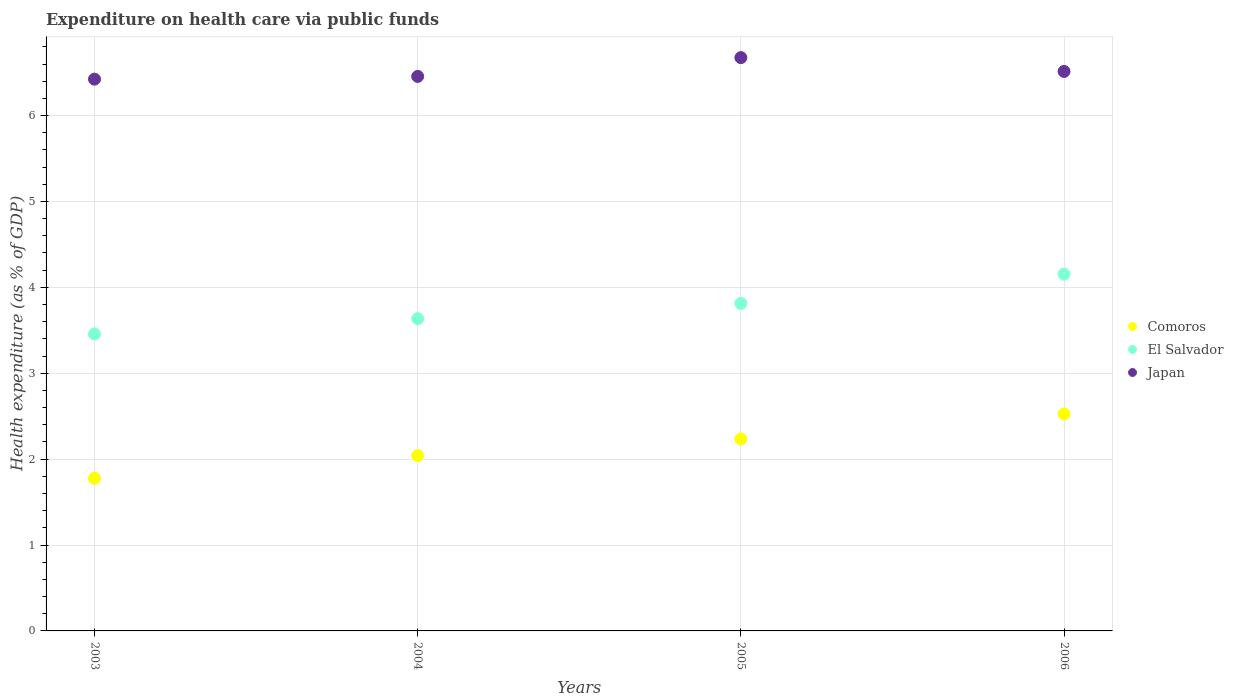Is the number of dotlines equal to the number of legend labels?
Your answer should be very brief. Yes. What is the expenditure made on health care in Japan in 2003?
Provide a short and direct response. 6.42. Across all years, what is the maximum expenditure made on health care in Comoros?
Give a very brief answer. 2.53. Across all years, what is the minimum expenditure made on health care in Japan?
Your answer should be compact. 6.42. In which year was the expenditure made on health care in El Salvador minimum?
Offer a very short reply. 2003. What is the total expenditure made on health care in Japan in the graph?
Your answer should be very brief. 26.07. What is the difference between the expenditure made on health care in Japan in 2003 and that in 2004?
Ensure brevity in your answer.  -0.03. What is the difference between the expenditure made on health care in Comoros in 2006 and the expenditure made on health care in El Salvador in 2005?
Your answer should be very brief. -1.29. What is the average expenditure made on health care in Comoros per year?
Your response must be concise. 2.14. In the year 2006, what is the difference between the expenditure made on health care in Comoros and expenditure made on health care in El Salvador?
Give a very brief answer. -1.63. What is the ratio of the expenditure made on health care in Comoros in 2003 to that in 2005?
Make the answer very short. 0.8. Is the difference between the expenditure made on health care in Comoros in 2004 and 2005 greater than the difference between the expenditure made on health care in El Salvador in 2004 and 2005?
Your answer should be very brief. No. What is the difference between the highest and the second highest expenditure made on health care in Comoros?
Make the answer very short. 0.29. What is the difference between the highest and the lowest expenditure made on health care in Japan?
Provide a succinct answer. 0.25. In how many years, is the expenditure made on health care in El Salvador greater than the average expenditure made on health care in El Salvador taken over all years?
Keep it short and to the point. 2. Is the sum of the expenditure made on health care in El Salvador in 2003 and 2006 greater than the maximum expenditure made on health care in Japan across all years?
Keep it short and to the point. Yes. Is it the case that in every year, the sum of the expenditure made on health care in El Salvador and expenditure made on health care in Japan  is greater than the expenditure made on health care in Comoros?
Make the answer very short. Yes. Does the expenditure made on health care in Japan monotonically increase over the years?
Your answer should be compact. No. How many years are there in the graph?
Offer a very short reply. 4. What is the difference between two consecutive major ticks on the Y-axis?
Provide a succinct answer. 1. Does the graph contain any zero values?
Ensure brevity in your answer.  No. How many legend labels are there?
Keep it short and to the point. 3. How are the legend labels stacked?
Offer a very short reply. Vertical. What is the title of the graph?
Offer a terse response. Expenditure on health care via public funds. Does "Ireland" appear as one of the legend labels in the graph?
Provide a short and direct response. No. What is the label or title of the X-axis?
Provide a short and direct response. Years. What is the label or title of the Y-axis?
Make the answer very short. Health expenditure (as % of GDP). What is the Health expenditure (as % of GDP) of Comoros in 2003?
Keep it short and to the point. 1.78. What is the Health expenditure (as % of GDP) of El Salvador in 2003?
Make the answer very short. 3.46. What is the Health expenditure (as % of GDP) in Japan in 2003?
Your response must be concise. 6.42. What is the Health expenditure (as % of GDP) of Comoros in 2004?
Your response must be concise. 2.04. What is the Health expenditure (as % of GDP) of El Salvador in 2004?
Your response must be concise. 3.64. What is the Health expenditure (as % of GDP) in Japan in 2004?
Your answer should be very brief. 6.46. What is the Health expenditure (as % of GDP) in Comoros in 2005?
Give a very brief answer. 2.23. What is the Health expenditure (as % of GDP) of El Salvador in 2005?
Your response must be concise. 3.81. What is the Health expenditure (as % of GDP) of Japan in 2005?
Your answer should be very brief. 6.67. What is the Health expenditure (as % of GDP) of Comoros in 2006?
Your answer should be compact. 2.53. What is the Health expenditure (as % of GDP) in El Salvador in 2006?
Your answer should be very brief. 4.15. What is the Health expenditure (as % of GDP) of Japan in 2006?
Your response must be concise. 6.51. Across all years, what is the maximum Health expenditure (as % of GDP) in Comoros?
Your response must be concise. 2.53. Across all years, what is the maximum Health expenditure (as % of GDP) of El Salvador?
Give a very brief answer. 4.15. Across all years, what is the maximum Health expenditure (as % of GDP) in Japan?
Offer a very short reply. 6.67. Across all years, what is the minimum Health expenditure (as % of GDP) in Comoros?
Offer a terse response. 1.78. Across all years, what is the minimum Health expenditure (as % of GDP) in El Salvador?
Your answer should be very brief. 3.46. Across all years, what is the minimum Health expenditure (as % of GDP) of Japan?
Provide a short and direct response. 6.42. What is the total Health expenditure (as % of GDP) in Comoros in the graph?
Your answer should be compact. 8.58. What is the total Health expenditure (as % of GDP) in El Salvador in the graph?
Your answer should be very brief. 15.06. What is the total Health expenditure (as % of GDP) of Japan in the graph?
Offer a terse response. 26.07. What is the difference between the Health expenditure (as % of GDP) of Comoros in 2003 and that in 2004?
Provide a succinct answer. -0.27. What is the difference between the Health expenditure (as % of GDP) in El Salvador in 2003 and that in 2004?
Offer a very short reply. -0.18. What is the difference between the Health expenditure (as % of GDP) in Japan in 2003 and that in 2004?
Provide a short and direct response. -0.03. What is the difference between the Health expenditure (as % of GDP) of Comoros in 2003 and that in 2005?
Provide a succinct answer. -0.46. What is the difference between the Health expenditure (as % of GDP) in El Salvador in 2003 and that in 2005?
Your answer should be compact. -0.36. What is the difference between the Health expenditure (as % of GDP) in Japan in 2003 and that in 2005?
Keep it short and to the point. -0.25. What is the difference between the Health expenditure (as % of GDP) of Comoros in 2003 and that in 2006?
Provide a succinct answer. -0.75. What is the difference between the Health expenditure (as % of GDP) in El Salvador in 2003 and that in 2006?
Your response must be concise. -0.7. What is the difference between the Health expenditure (as % of GDP) in Japan in 2003 and that in 2006?
Your answer should be compact. -0.09. What is the difference between the Health expenditure (as % of GDP) in Comoros in 2004 and that in 2005?
Make the answer very short. -0.19. What is the difference between the Health expenditure (as % of GDP) of El Salvador in 2004 and that in 2005?
Keep it short and to the point. -0.18. What is the difference between the Health expenditure (as % of GDP) of Japan in 2004 and that in 2005?
Ensure brevity in your answer.  -0.22. What is the difference between the Health expenditure (as % of GDP) of Comoros in 2004 and that in 2006?
Keep it short and to the point. -0.48. What is the difference between the Health expenditure (as % of GDP) in El Salvador in 2004 and that in 2006?
Your response must be concise. -0.52. What is the difference between the Health expenditure (as % of GDP) in Japan in 2004 and that in 2006?
Your answer should be very brief. -0.06. What is the difference between the Health expenditure (as % of GDP) of Comoros in 2005 and that in 2006?
Give a very brief answer. -0.29. What is the difference between the Health expenditure (as % of GDP) in El Salvador in 2005 and that in 2006?
Provide a succinct answer. -0.34. What is the difference between the Health expenditure (as % of GDP) of Japan in 2005 and that in 2006?
Give a very brief answer. 0.16. What is the difference between the Health expenditure (as % of GDP) in Comoros in 2003 and the Health expenditure (as % of GDP) in El Salvador in 2004?
Ensure brevity in your answer.  -1.86. What is the difference between the Health expenditure (as % of GDP) in Comoros in 2003 and the Health expenditure (as % of GDP) in Japan in 2004?
Your answer should be very brief. -4.68. What is the difference between the Health expenditure (as % of GDP) of El Salvador in 2003 and the Health expenditure (as % of GDP) of Japan in 2004?
Provide a short and direct response. -3. What is the difference between the Health expenditure (as % of GDP) in Comoros in 2003 and the Health expenditure (as % of GDP) in El Salvador in 2005?
Your answer should be very brief. -2.04. What is the difference between the Health expenditure (as % of GDP) in Comoros in 2003 and the Health expenditure (as % of GDP) in Japan in 2005?
Ensure brevity in your answer.  -4.9. What is the difference between the Health expenditure (as % of GDP) in El Salvador in 2003 and the Health expenditure (as % of GDP) in Japan in 2005?
Offer a terse response. -3.22. What is the difference between the Health expenditure (as % of GDP) in Comoros in 2003 and the Health expenditure (as % of GDP) in El Salvador in 2006?
Provide a succinct answer. -2.38. What is the difference between the Health expenditure (as % of GDP) of Comoros in 2003 and the Health expenditure (as % of GDP) of Japan in 2006?
Provide a short and direct response. -4.74. What is the difference between the Health expenditure (as % of GDP) of El Salvador in 2003 and the Health expenditure (as % of GDP) of Japan in 2006?
Offer a very short reply. -3.06. What is the difference between the Health expenditure (as % of GDP) of Comoros in 2004 and the Health expenditure (as % of GDP) of El Salvador in 2005?
Keep it short and to the point. -1.77. What is the difference between the Health expenditure (as % of GDP) in Comoros in 2004 and the Health expenditure (as % of GDP) in Japan in 2005?
Your answer should be very brief. -4.63. What is the difference between the Health expenditure (as % of GDP) of El Salvador in 2004 and the Health expenditure (as % of GDP) of Japan in 2005?
Your response must be concise. -3.04. What is the difference between the Health expenditure (as % of GDP) in Comoros in 2004 and the Health expenditure (as % of GDP) in El Salvador in 2006?
Provide a succinct answer. -2.11. What is the difference between the Health expenditure (as % of GDP) of Comoros in 2004 and the Health expenditure (as % of GDP) of Japan in 2006?
Make the answer very short. -4.47. What is the difference between the Health expenditure (as % of GDP) in El Salvador in 2004 and the Health expenditure (as % of GDP) in Japan in 2006?
Make the answer very short. -2.88. What is the difference between the Health expenditure (as % of GDP) in Comoros in 2005 and the Health expenditure (as % of GDP) in El Salvador in 2006?
Give a very brief answer. -1.92. What is the difference between the Health expenditure (as % of GDP) in Comoros in 2005 and the Health expenditure (as % of GDP) in Japan in 2006?
Your answer should be compact. -4.28. What is the difference between the Health expenditure (as % of GDP) in El Salvador in 2005 and the Health expenditure (as % of GDP) in Japan in 2006?
Ensure brevity in your answer.  -2.7. What is the average Health expenditure (as % of GDP) in Comoros per year?
Make the answer very short. 2.14. What is the average Health expenditure (as % of GDP) in El Salvador per year?
Keep it short and to the point. 3.76. What is the average Health expenditure (as % of GDP) of Japan per year?
Your answer should be compact. 6.52. In the year 2003, what is the difference between the Health expenditure (as % of GDP) of Comoros and Health expenditure (as % of GDP) of El Salvador?
Give a very brief answer. -1.68. In the year 2003, what is the difference between the Health expenditure (as % of GDP) in Comoros and Health expenditure (as % of GDP) in Japan?
Make the answer very short. -4.65. In the year 2003, what is the difference between the Health expenditure (as % of GDP) of El Salvador and Health expenditure (as % of GDP) of Japan?
Your response must be concise. -2.97. In the year 2004, what is the difference between the Health expenditure (as % of GDP) of Comoros and Health expenditure (as % of GDP) of El Salvador?
Make the answer very short. -1.59. In the year 2004, what is the difference between the Health expenditure (as % of GDP) in Comoros and Health expenditure (as % of GDP) in Japan?
Your response must be concise. -4.41. In the year 2004, what is the difference between the Health expenditure (as % of GDP) of El Salvador and Health expenditure (as % of GDP) of Japan?
Make the answer very short. -2.82. In the year 2005, what is the difference between the Health expenditure (as % of GDP) of Comoros and Health expenditure (as % of GDP) of El Salvador?
Provide a short and direct response. -1.58. In the year 2005, what is the difference between the Health expenditure (as % of GDP) in Comoros and Health expenditure (as % of GDP) in Japan?
Provide a succinct answer. -4.44. In the year 2005, what is the difference between the Health expenditure (as % of GDP) of El Salvador and Health expenditure (as % of GDP) of Japan?
Ensure brevity in your answer.  -2.86. In the year 2006, what is the difference between the Health expenditure (as % of GDP) of Comoros and Health expenditure (as % of GDP) of El Salvador?
Offer a very short reply. -1.63. In the year 2006, what is the difference between the Health expenditure (as % of GDP) of Comoros and Health expenditure (as % of GDP) of Japan?
Your response must be concise. -3.99. In the year 2006, what is the difference between the Health expenditure (as % of GDP) in El Salvador and Health expenditure (as % of GDP) in Japan?
Provide a succinct answer. -2.36. What is the ratio of the Health expenditure (as % of GDP) of Comoros in 2003 to that in 2004?
Ensure brevity in your answer.  0.87. What is the ratio of the Health expenditure (as % of GDP) of El Salvador in 2003 to that in 2004?
Your answer should be very brief. 0.95. What is the ratio of the Health expenditure (as % of GDP) of Comoros in 2003 to that in 2005?
Offer a very short reply. 0.8. What is the ratio of the Health expenditure (as % of GDP) in El Salvador in 2003 to that in 2005?
Your response must be concise. 0.91. What is the ratio of the Health expenditure (as % of GDP) of Japan in 2003 to that in 2005?
Give a very brief answer. 0.96. What is the ratio of the Health expenditure (as % of GDP) in Comoros in 2003 to that in 2006?
Give a very brief answer. 0.7. What is the ratio of the Health expenditure (as % of GDP) of El Salvador in 2003 to that in 2006?
Provide a succinct answer. 0.83. What is the ratio of the Health expenditure (as % of GDP) of Japan in 2003 to that in 2006?
Make the answer very short. 0.99. What is the ratio of the Health expenditure (as % of GDP) in Comoros in 2004 to that in 2005?
Ensure brevity in your answer.  0.91. What is the ratio of the Health expenditure (as % of GDP) in El Salvador in 2004 to that in 2005?
Ensure brevity in your answer.  0.95. What is the ratio of the Health expenditure (as % of GDP) in Japan in 2004 to that in 2005?
Make the answer very short. 0.97. What is the ratio of the Health expenditure (as % of GDP) in Comoros in 2004 to that in 2006?
Give a very brief answer. 0.81. What is the ratio of the Health expenditure (as % of GDP) in El Salvador in 2004 to that in 2006?
Give a very brief answer. 0.88. What is the ratio of the Health expenditure (as % of GDP) in Comoros in 2005 to that in 2006?
Offer a terse response. 0.89. What is the ratio of the Health expenditure (as % of GDP) in El Salvador in 2005 to that in 2006?
Ensure brevity in your answer.  0.92. What is the ratio of the Health expenditure (as % of GDP) of Japan in 2005 to that in 2006?
Your answer should be very brief. 1.02. What is the difference between the highest and the second highest Health expenditure (as % of GDP) of Comoros?
Provide a succinct answer. 0.29. What is the difference between the highest and the second highest Health expenditure (as % of GDP) of El Salvador?
Give a very brief answer. 0.34. What is the difference between the highest and the second highest Health expenditure (as % of GDP) of Japan?
Give a very brief answer. 0.16. What is the difference between the highest and the lowest Health expenditure (as % of GDP) of Comoros?
Ensure brevity in your answer.  0.75. What is the difference between the highest and the lowest Health expenditure (as % of GDP) of El Salvador?
Make the answer very short. 0.7. What is the difference between the highest and the lowest Health expenditure (as % of GDP) of Japan?
Provide a short and direct response. 0.25. 